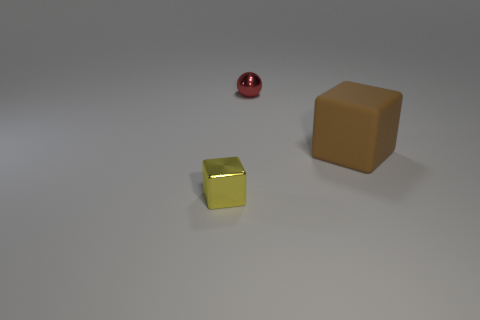What material is the block on the right side of the thing that is in front of the thing on the right side of the tiny red metal object made of?
Your response must be concise. Rubber. Is the color of the tiny ball the same as the shiny thing in front of the matte block?
Your answer should be very brief. No. What number of objects are small objects that are to the right of the yellow object or tiny things in front of the rubber object?
Provide a succinct answer. 2. What is the shape of the object that is on the right side of the tiny metal thing on the right side of the small block?
Your answer should be very brief. Cube. Are there any tiny things that have the same material as the big cube?
Provide a short and direct response. No. What is the color of the big object that is the same shape as the small yellow thing?
Keep it short and to the point. Brown. Is the number of small yellow metal cubes to the right of the small yellow thing less than the number of matte blocks that are in front of the big matte object?
Give a very brief answer. No. How many other things are there of the same shape as the small yellow thing?
Provide a short and direct response. 1. Is the number of big matte blocks that are right of the brown matte cube less than the number of green shiny balls?
Make the answer very short. No. There is a small thing that is in front of the small red sphere; what is it made of?
Offer a very short reply. Metal. 